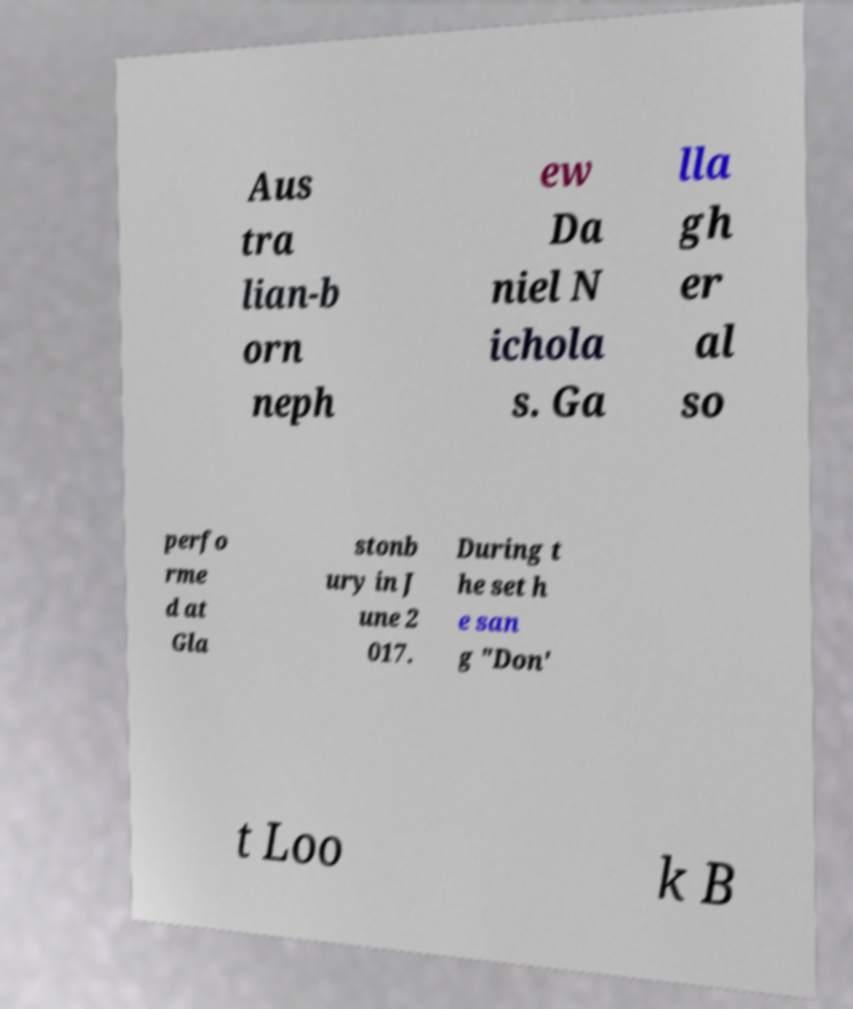Please read and relay the text visible in this image. What does it say? Aus tra lian-b orn neph ew Da niel N ichola s. Ga lla gh er al so perfo rme d at Gla stonb ury in J une 2 017. During t he set h e san g "Don' t Loo k B 